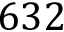Convert formula to latex. <formula><loc_0><loc_0><loc_500><loc_500>6 3 2</formula> 